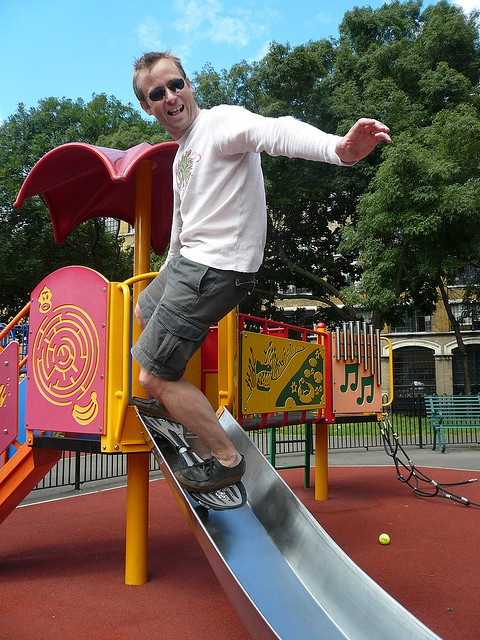Describe the objects in this image and their specific colors. I can see people in lightblue, white, darkgray, black, and gray tones, skateboard in lightblue, black, gray, darkgray, and maroon tones, bench in lightblue, black, and teal tones, and sports ball in lightblue, khaki, and olive tones in this image. 